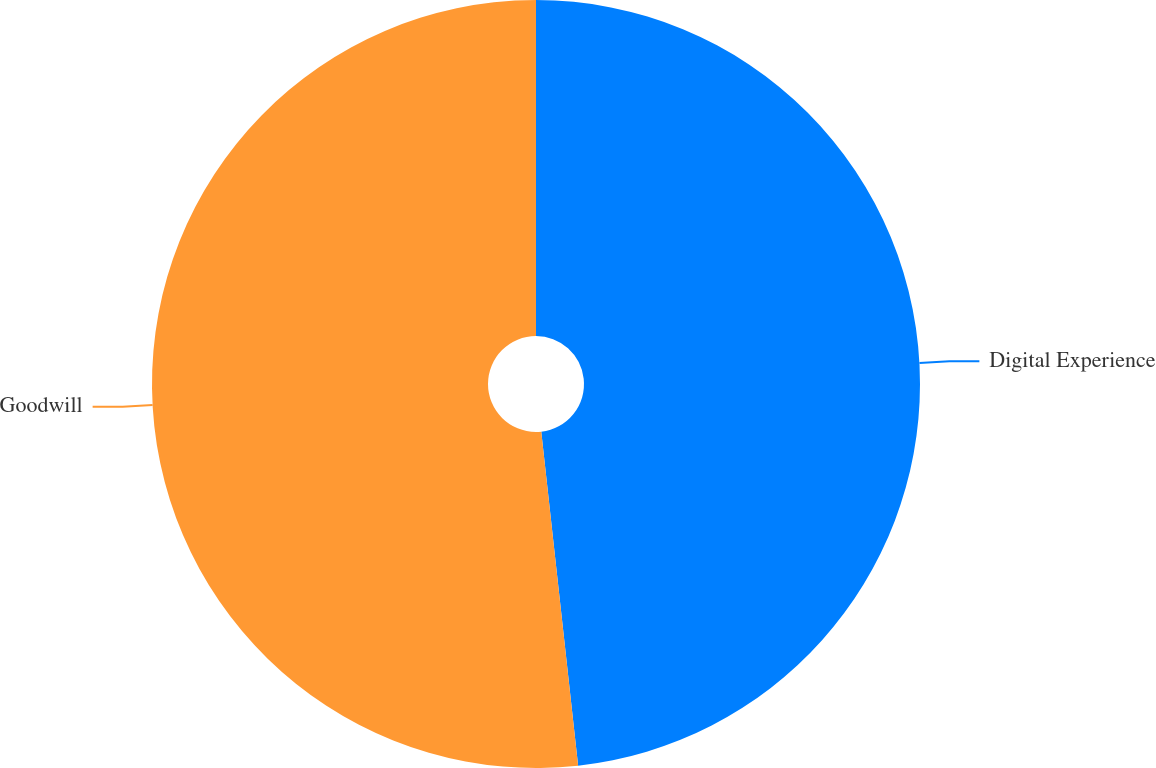<chart> <loc_0><loc_0><loc_500><loc_500><pie_chart><fcel>Digital Experience<fcel>Goodwill<nl><fcel>48.25%<fcel>51.75%<nl></chart> 